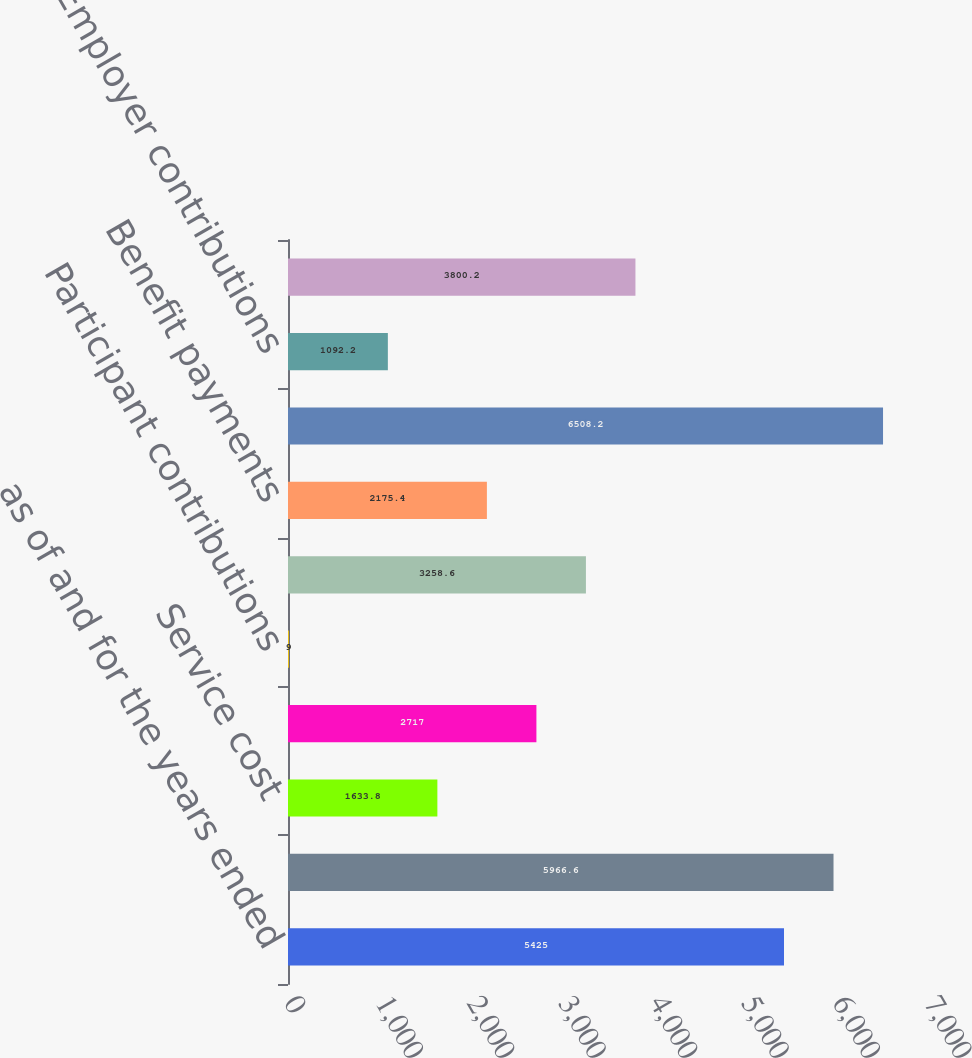Convert chart to OTSL. <chart><loc_0><loc_0><loc_500><loc_500><bar_chart><fcel>as of and for the years ended<fcel>Beginning of period<fcel>Service cost<fcel>Interest cost<fcel>Participant contributions<fcel>Actuarial (gain)/loss<fcel>Benefit payments<fcel>End of period<fcel>Employer contributions<fcel>Funded status at December 31<nl><fcel>5425<fcel>5966.6<fcel>1633.8<fcel>2717<fcel>9<fcel>3258.6<fcel>2175.4<fcel>6508.2<fcel>1092.2<fcel>3800.2<nl></chart> 